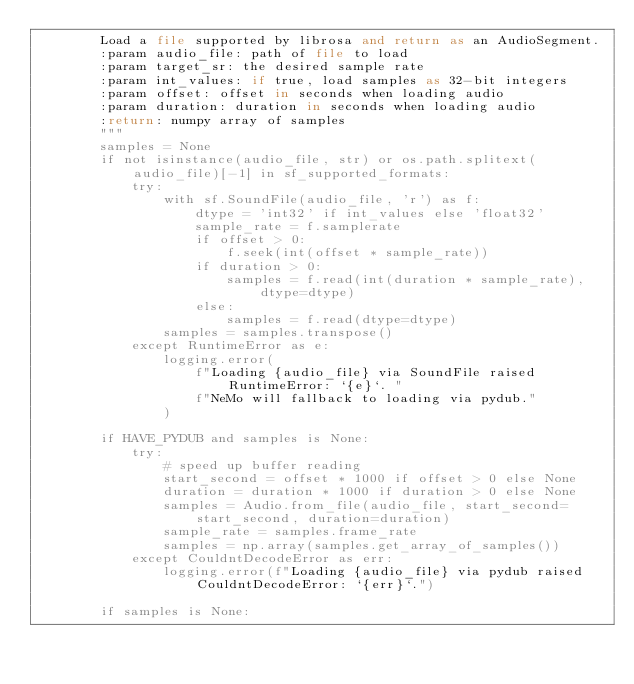Convert code to text. <code><loc_0><loc_0><loc_500><loc_500><_Python_>        Load a file supported by librosa and return as an AudioSegment.
        :param audio_file: path of file to load
        :param target_sr: the desired sample rate
        :param int_values: if true, load samples as 32-bit integers
        :param offset: offset in seconds when loading audio
        :param duration: duration in seconds when loading audio
        :return: numpy array of samples
        """
        samples = None
        if not isinstance(audio_file, str) or os.path.splitext(audio_file)[-1] in sf_supported_formats:
            try:
                with sf.SoundFile(audio_file, 'r') as f:
                    dtype = 'int32' if int_values else 'float32'
                    sample_rate = f.samplerate
                    if offset > 0:
                        f.seek(int(offset * sample_rate))
                    if duration > 0:
                        samples = f.read(int(duration * sample_rate), dtype=dtype)
                    else:
                        samples = f.read(dtype=dtype)
                samples = samples.transpose()
            except RuntimeError as e:
                logging.error(
                    f"Loading {audio_file} via SoundFile raised RuntimeError: `{e}`. "
                    f"NeMo will fallback to loading via pydub."
                )

        if HAVE_PYDUB and samples is None:
            try:
                # speed up buffer reading
                start_second = offset * 1000 if offset > 0 else None
                duration = duration * 1000 if duration > 0 else None
                samples = Audio.from_file(audio_file, start_second=start_second, duration=duration)
                sample_rate = samples.frame_rate
                samples = np.array(samples.get_array_of_samples())
            except CouldntDecodeError as err:
                logging.error(f"Loading {audio_file} via pydub raised CouldntDecodeError: `{err}`.")

        if samples is None:</code> 